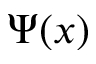<formula> <loc_0><loc_0><loc_500><loc_500>\Psi ( x )</formula> 